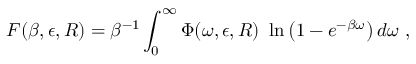Convert formula to latex. <formula><loc_0><loc_0><loc_500><loc_500>F ( \beta , \epsilon , R ) = \beta ^ { - 1 } \int _ { 0 } ^ { \infty } \Phi ( \omega , \epsilon , R ) \ln \left ( 1 - e ^ { - \beta \omega } \right ) d \omega ,</formula> 